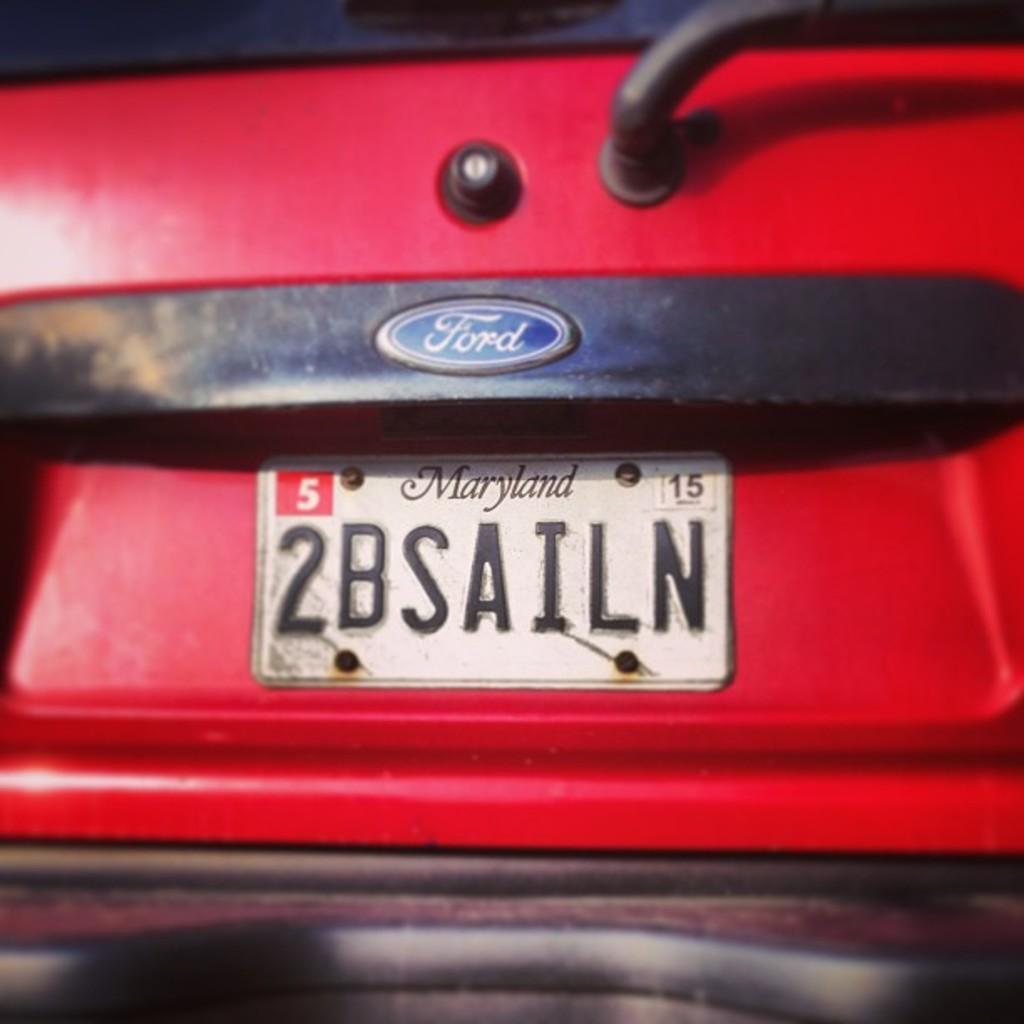Can you describe this image briefly? In this image I can see a red and black color car. In front I can see white color number plate. 